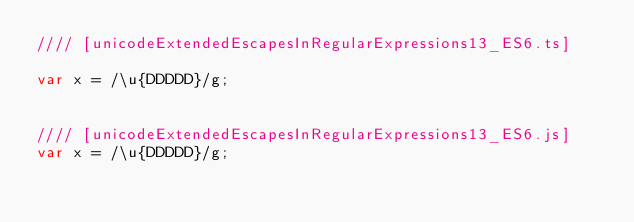<code> <loc_0><loc_0><loc_500><loc_500><_JavaScript_>//// [unicodeExtendedEscapesInRegularExpressions13_ES6.ts]

var x = /\u{DDDDD}/g;


//// [unicodeExtendedEscapesInRegularExpressions13_ES6.js]
var x = /\u{DDDDD}/g;
</code> 